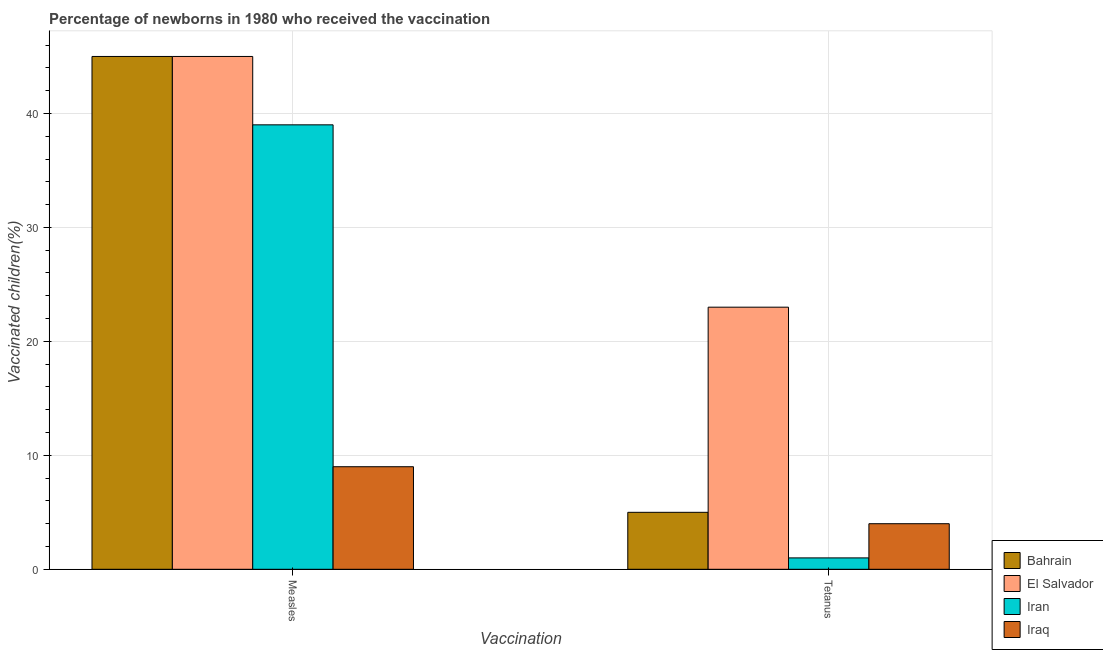How many different coloured bars are there?
Keep it short and to the point. 4. How many groups of bars are there?
Ensure brevity in your answer.  2. Are the number of bars per tick equal to the number of legend labels?
Provide a succinct answer. Yes. How many bars are there on the 2nd tick from the left?
Your response must be concise. 4. How many bars are there on the 1st tick from the right?
Provide a short and direct response. 4. What is the label of the 1st group of bars from the left?
Your response must be concise. Measles. What is the percentage of newborns who received vaccination for measles in Iran?
Offer a very short reply. 39. Across all countries, what is the maximum percentage of newborns who received vaccination for tetanus?
Your answer should be very brief. 23. Across all countries, what is the minimum percentage of newborns who received vaccination for tetanus?
Provide a succinct answer. 1. In which country was the percentage of newborns who received vaccination for tetanus maximum?
Your answer should be compact. El Salvador. In which country was the percentage of newborns who received vaccination for measles minimum?
Your answer should be compact. Iraq. What is the total percentage of newborns who received vaccination for measles in the graph?
Your answer should be compact. 138. What is the difference between the percentage of newborns who received vaccination for tetanus in Iraq and that in El Salvador?
Your answer should be very brief. -19. What is the difference between the percentage of newborns who received vaccination for tetanus in Bahrain and the percentage of newborns who received vaccination for measles in Iran?
Make the answer very short. -34. What is the average percentage of newborns who received vaccination for measles per country?
Keep it short and to the point. 34.5. What is the difference between the percentage of newborns who received vaccination for measles and percentage of newborns who received vaccination for tetanus in Bahrain?
Your answer should be compact. 40. What is the ratio of the percentage of newborns who received vaccination for tetanus in El Salvador to that in Iraq?
Ensure brevity in your answer.  5.75. Is the percentage of newborns who received vaccination for measles in Iran less than that in Bahrain?
Provide a short and direct response. Yes. In how many countries, is the percentage of newborns who received vaccination for tetanus greater than the average percentage of newborns who received vaccination for tetanus taken over all countries?
Give a very brief answer. 1. What does the 1st bar from the left in Measles represents?
Offer a very short reply. Bahrain. What does the 1st bar from the right in Measles represents?
Provide a succinct answer. Iraq. Are all the bars in the graph horizontal?
Keep it short and to the point. No. What is the difference between two consecutive major ticks on the Y-axis?
Make the answer very short. 10. Does the graph contain any zero values?
Your response must be concise. No. Where does the legend appear in the graph?
Provide a succinct answer. Bottom right. How are the legend labels stacked?
Make the answer very short. Vertical. What is the title of the graph?
Offer a very short reply. Percentage of newborns in 1980 who received the vaccination. What is the label or title of the X-axis?
Ensure brevity in your answer.  Vaccination. What is the label or title of the Y-axis?
Ensure brevity in your answer.  Vaccinated children(%)
. What is the Vaccinated children(%)
 of Bahrain in Measles?
Your response must be concise. 45. What is the Vaccinated children(%)
 in El Salvador in Measles?
Offer a terse response. 45. What is the Vaccinated children(%)
 in Iran in Measles?
Provide a succinct answer. 39. What is the Vaccinated children(%)
 in Iraq in Measles?
Give a very brief answer. 9. What is the Vaccinated children(%)
 in Bahrain in Tetanus?
Your answer should be compact. 5. Across all Vaccination, what is the maximum Vaccinated children(%)
 in El Salvador?
Keep it short and to the point. 45. Across all Vaccination, what is the maximum Vaccinated children(%)
 in Iran?
Offer a terse response. 39. Across all Vaccination, what is the maximum Vaccinated children(%)
 of Iraq?
Your answer should be very brief. 9. Across all Vaccination, what is the minimum Vaccinated children(%)
 in Bahrain?
Your response must be concise. 5. Across all Vaccination, what is the minimum Vaccinated children(%)
 of Iran?
Offer a very short reply. 1. Across all Vaccination, what is the minimum Vaccinated children(%)
 of Iraq?
Your answer should be compact. 4. What is the total Vaccinated children(%)
 in Bahrain in the graph?
Offer a terse response. 50. What is the total Vaccinated children(%)
 of El Salvador in the graph?
Offer a terse response. 68. What is the total Vaccinated children(%)
 of Iran in the graph?
Provide a short and direct response. 40. What is the difference between the Vaccinated children(%)
 in Iraq in Measles and that in Tetanus?
Your answer should be compact. 5. What is the difference between the Vaccinated children(%)
 of Bahrain in Measles and the Vaccinated children(%)
 of El Salvador in Tetanus?
Provide a short and direct response. 22. What is the difference between the Vaccinated children(%)
 in Bahrain in Measles and the Vaccinated children(%)
 in Iran in Tetanus?
Make the answer very short. 44. What is the difference between the Vaccinated children(%)
 in Bahrain in Measles and the Vaccinated children(%)
 in Iraq in Tetanus?
Ensure brevity in your answer.  41. What is the difference between the Vaccinated children(%)
 of El Salvador in Measles and the Vaccinated children(%)
 of Iran in Tetanus?
Provide a short and direct response. 44. What is the difference between the Vaccinated children(%)
 of Iran in Measles and the Vaccinated children(%)
 of Iraq in Tetanus?
Offer a terse response. 35. What is the average Vaccinated children(%)
 in Bahrain per Vaccination?
Your response must be concise. 25. What is the average Vaccinated children(%)
 of El Salvador per Vaccination?
Make the answer very short. 34. What is the average Vaccinated children(%)
 in Iran per Vaccination?
Ensure brevity in your answer.  20. What is the average Vaccinated children(%)
 in Iraq per Vaccination?
Provide a succinct answer. 6.5. What is the difference between the Vaccinated children(%)
 of Bahrain and Vaccinated children(%)
 of El Salvador in Measles?
Provide a short and direct response. 0. What is the difference between the Vaccinated children(%)
 in Bahrain and Vaccinated children(%)
 in Iran in Measles?
Provide a short and direct response. 6. What is the difference between the Vaccinated children(%)
 of El Salvador and Vaccinated children(%)
 of Iran in Measles?
Make the answer very short. 6. What is the difference between the Vaccinated children(%)
 of Iran and Vaccinated children(%)
 of Iraq in Measles?
Ensure brevity in your answer.  30. What is the difference between the Vaccinated children(%)
 of Bahrain and Vaccinated children(%)
 of El Salvador in Tetanus?
Your answer should be compact. -18. What is the difference between the Vaccinated children(%)
 of Iran and Vaccinated children(%)
 of Iraq in Tetanus?
Offer a very short reply. -3. What is the ratio of the Vaccinated children(%)
 of Bahrain in Measles to that in Tetanus?
Offer a very short reply. 9. What is the ratio of the Vaccinated children(%)
 of El Salvador in Measles to that in Tetanus?
Ensure brevity in your answer.  1.96. What is the ratio of the Vaccinated children(%)
 in Iraq in Measles to that in Tetanus?
Keep it short and to the point. 2.25. What is the difference between the highest and the second highest Vaccinated children(%)
 of Iran?
Your answer should be compact. 38. 